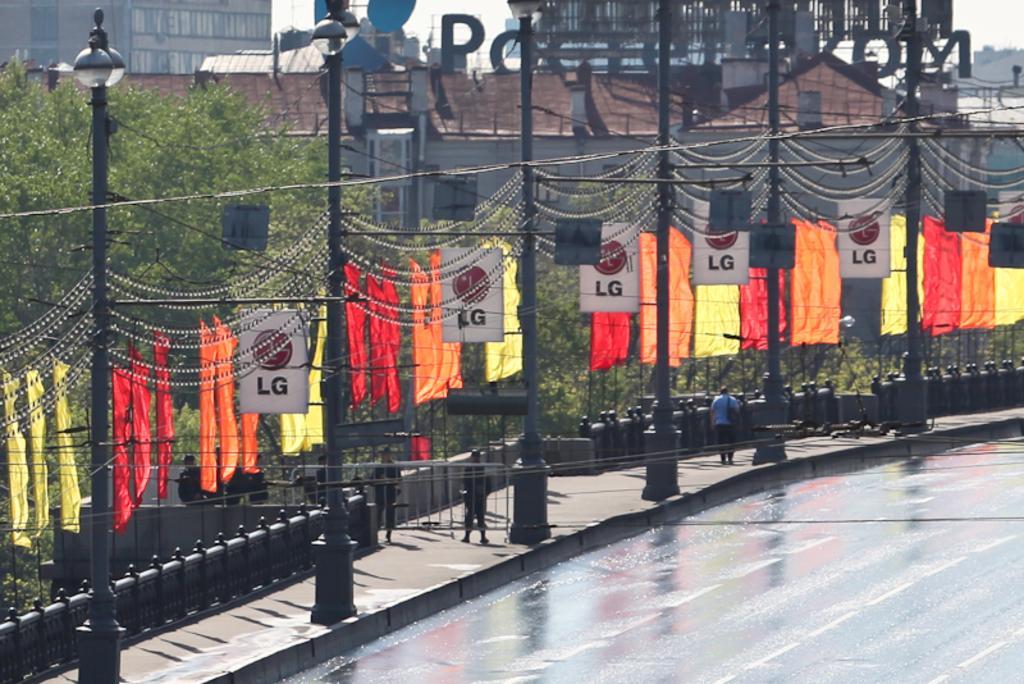How would you summarize this image in a sentence or two? Here we can see light poles, flags, hoardings and people. Background there are buildings with windows. These are trees. 